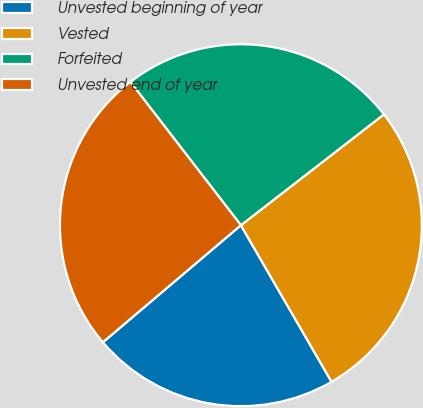Convert chart to OTSL. <chart><loc_0><loc_0><loc_500><loc_500><pie_chart><fcel>Unvested beginning of year<fcel>Vested<fcel>Forfeited<fcel>Unvested end of year<nl><fcel>22.16%<fcel>27.14%<fcel>24.96%<fcel>25.74%<nl></chart> 